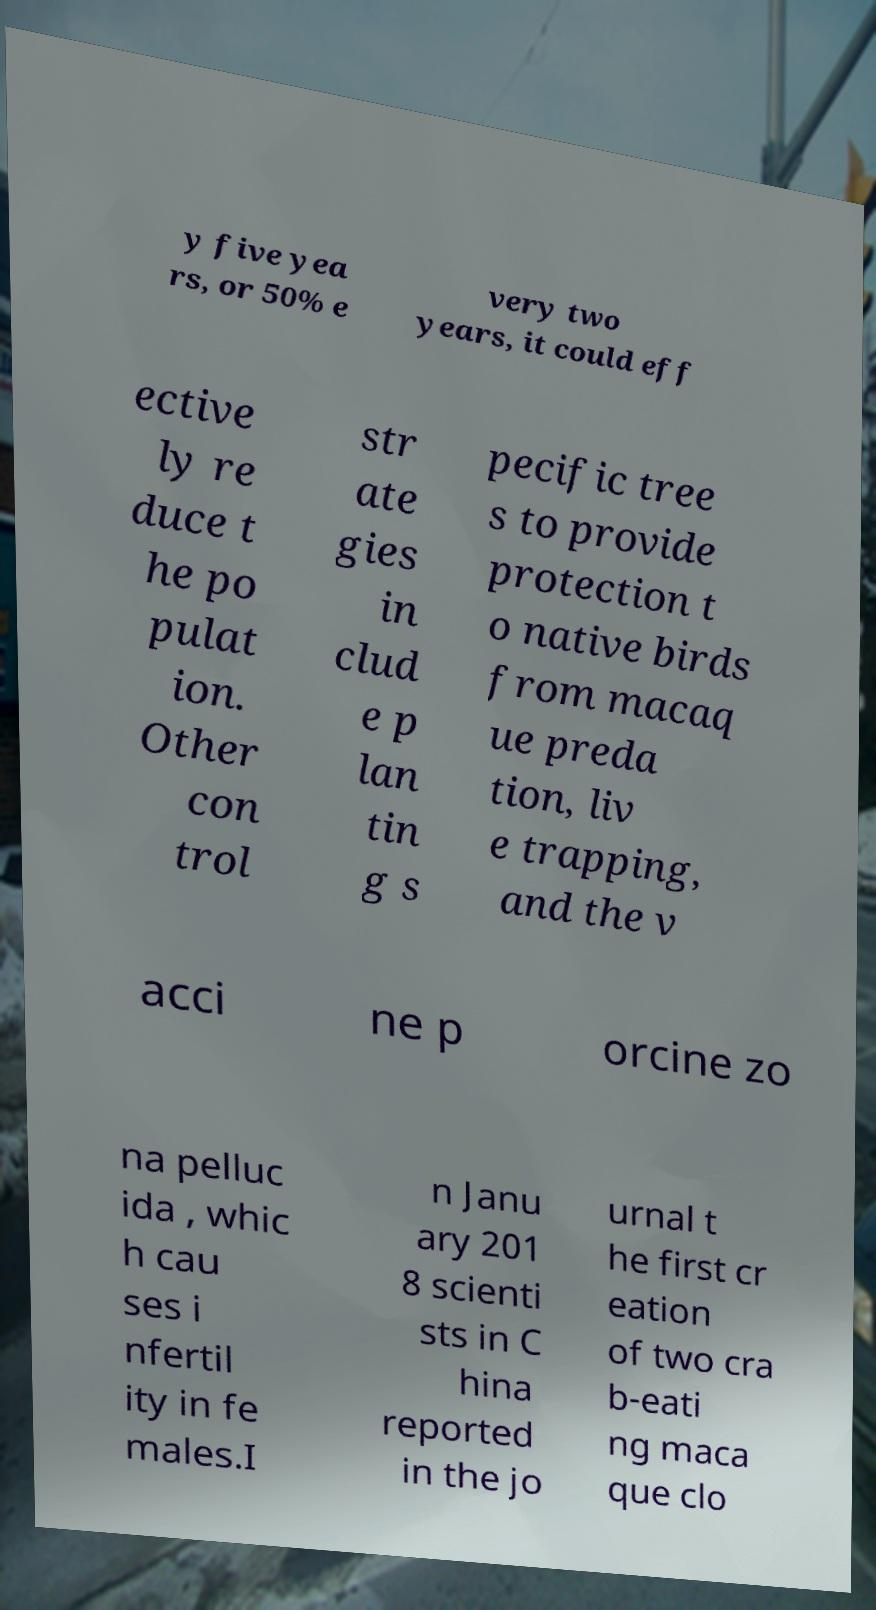Could you extract and type out the text from this image? y five yea rs, or 50% e very two years, it could eff ective ly re duce t he po pulat ion. Other con trol str ate gies in clud e p lan tin g s pecific tree s to provide protection t o native birds from macaq ue preda tion, liv e trapping, and the v acci ne p orcine zo na pelluc ida , whic h cau ses i nfertil ity in fe males.I n Janu ary 201 8 scienti sts in C hina reported in the jo urnal t he first cr eation of two cra b-eati ng maca que clo 